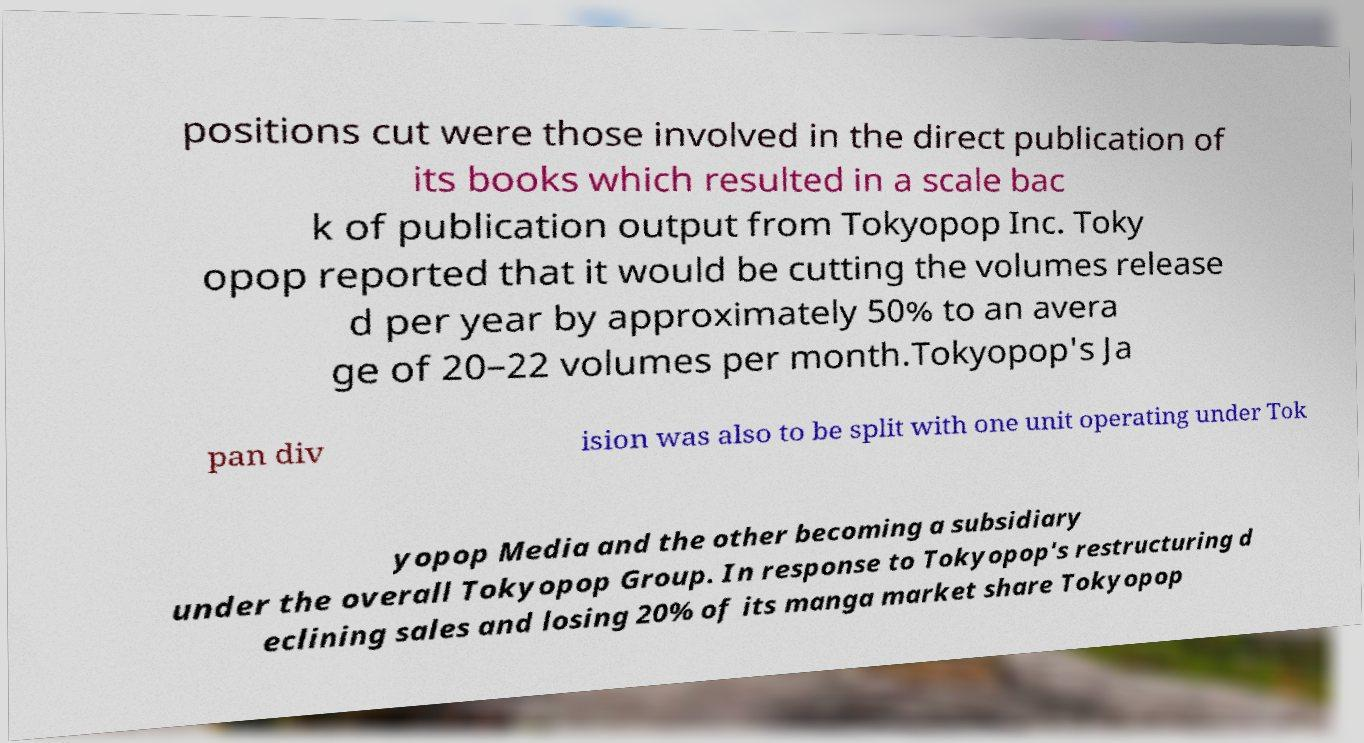Could you assist in decoding the text presented in this image and type it out clearly? positions cut were those involved in the direct publication of its books which resulted in a scale bac k of publication output from Tokyopop Inc. Toky opop reported that it would be cutting the volumes release d per year by approximately 50% to an avera ge of 20–22 volumes per month.Tokyopop's Ja pan div ision was also to be split with one unit operating under Tok yopop Media and the other becoming a subsidiary under the overall Tokyopop Group. In response to Tokyopop's restructuring d eclining sales and losing 20% of its manga market share Tokyopop 